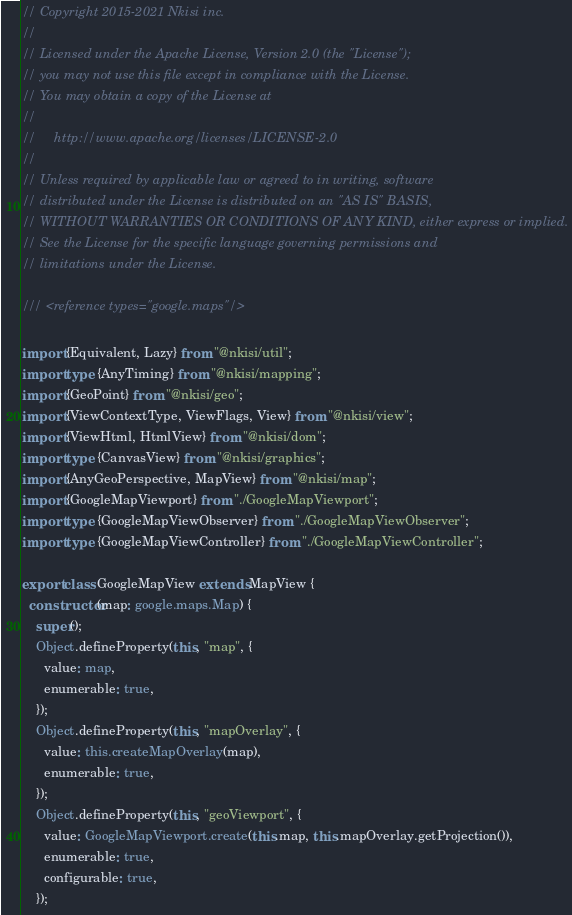Convert code to text. <code><loc_0><loc_0><loc_500><loc_500><_TypeScript_>// Copyright 2015-2021 Nkisi inc.
//
// Licensed under the Apache License, Version 2.0 (the "License");
// you may not use this file except in compliance with the License.
// You may obtain a copy of the License at
//
//     http://www.apache.org/licenses/LICENSE-2.0
//
// Unless required by applicable law or agreed to in writing, software
// distributed under the License is distributed on an "AS IS" BASIS,
// WITHOUT WARRANTIES OR CONDITIONS OF ANY KIND, either express or implied.
// See the License for the specific language governing permissions and
// limitations under the License.

/// <reference types="google.maps"/>

import {Equivalent, Lazy} from "@nkisi/util";
import type {AnyTiming} from "@nkisi/mapping";
import {GeoPoint} from "@nkisi/geo";
import {ViewContextType, ViewFlags, View} from "@nkisi/view";
import {ViewHtml, HtmlView} from "@nkisi/dom";
import type {CanvasView} from "@nkisi/graphics";
import {AnyGeoPerspective, MapView} from "@nkisi/map";
import {GoogleMapViewport} from "./GoogleMapViewport";
import type {GoogleMapViewObserver} from "./GoogleMapViewObserver";
import type {GoogleMapViewController} from "./GoogleMapViewController";

export class GoogleMapView extends MapView {
  constructor(map: google.maps.Map) {
    super();
    Object.defineProperty(this, "map", {
      value: map,
      enumerable: true,
    });
    Object.defineProperty(this, "mapOverlay", {
      value: this.createMapOverlay(map),
      enumerable: true,
    });
    Object.defineProperty(this, "geoViewport", {
      value: GoogleMapViewport.create(this.map, this.mapOverlay.getProjection()),
      enumerable: true,
      configurable: true,
    });</code> 